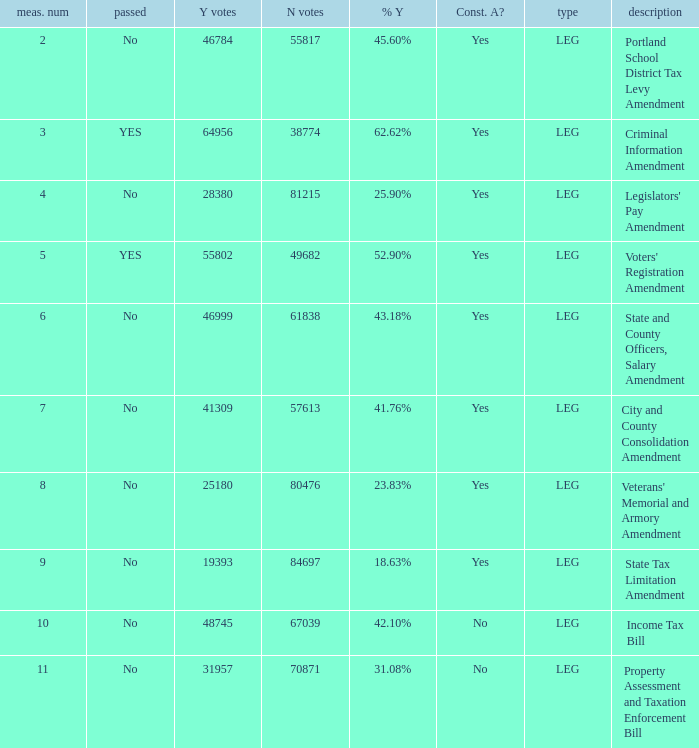How many yes votes made up 43.18% yes? 46999.0. 